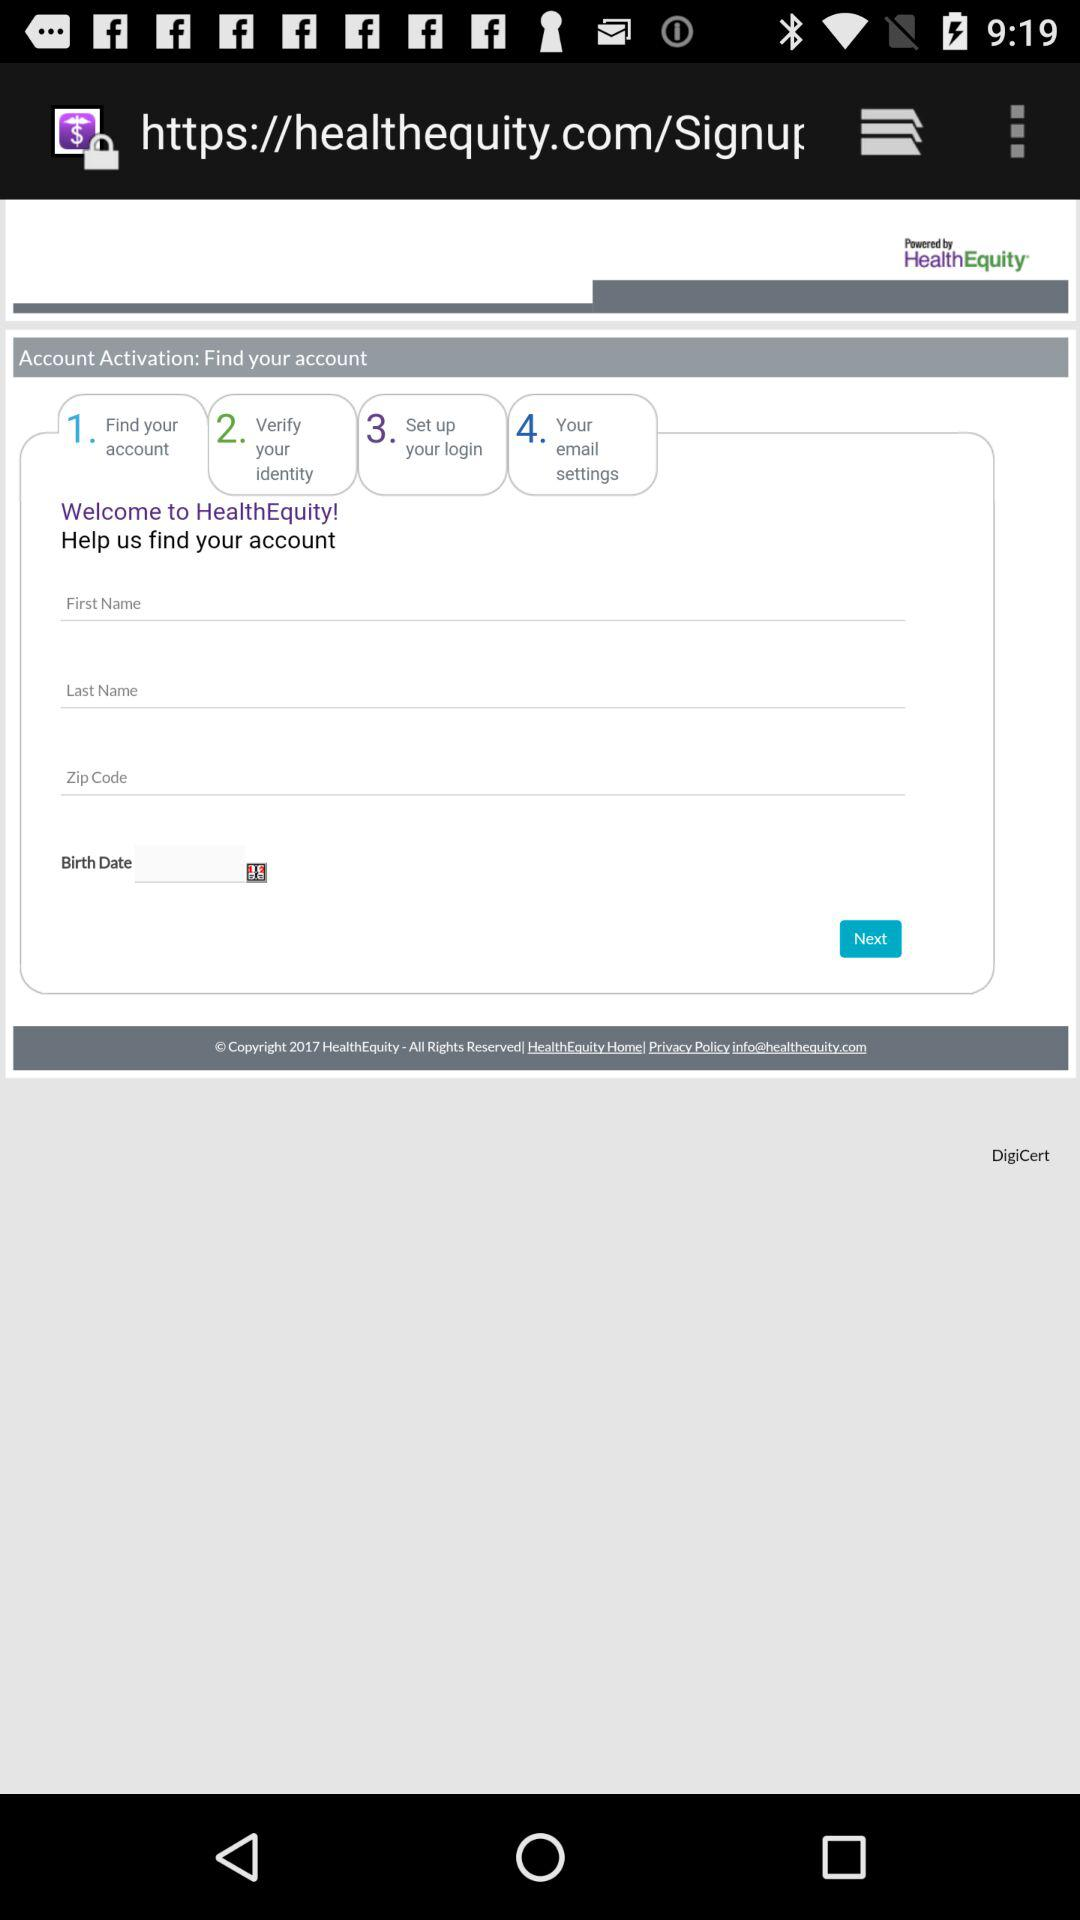How many steps are there in the account activation process?
Answer the question using a single word or phrase. 4 